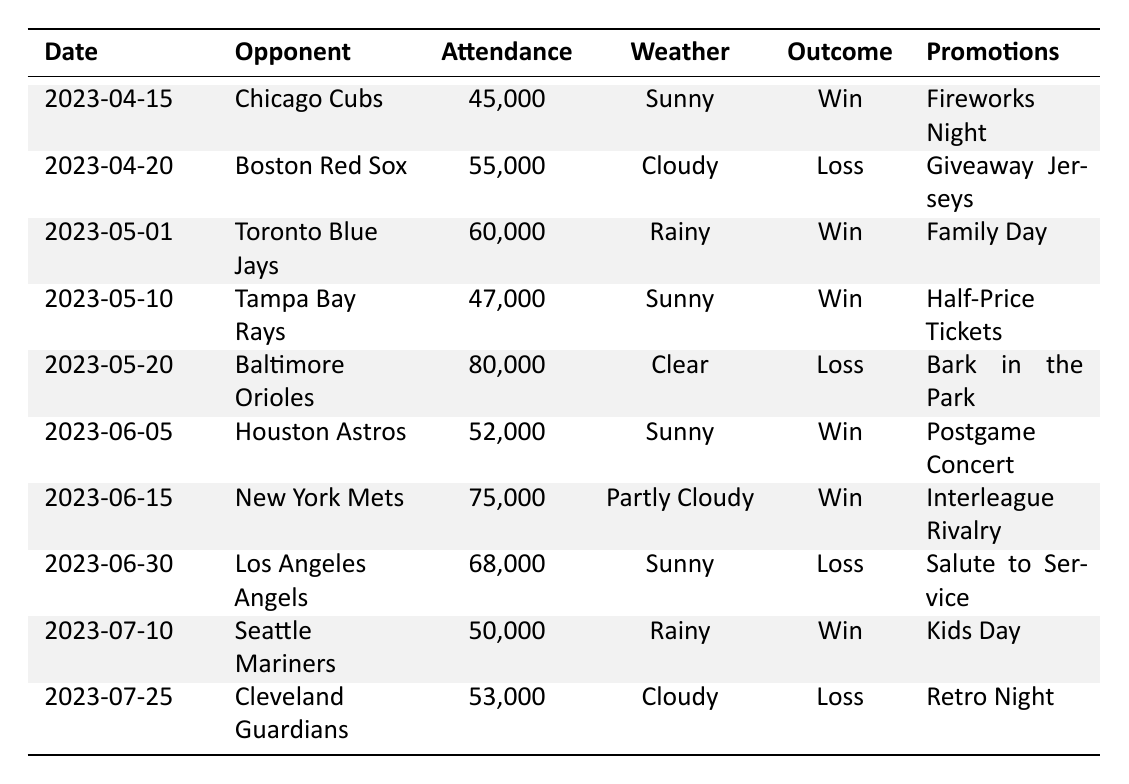What was the attendance for the game against the Baltimore Orioles on May 20, 2023? The attendance for the game against the Baltimore Orioles is listed in the table under Attendance for the date May 20, 2023. The value is 80,000.
Answer: 80,000 How many games did the New York Yankees win during this period? To determine the number of wins, we can count the rows where the Outcome is "Win". In the table, there are six wins on the dates: April 15, May 1, May 10, June 5, June 15, and July 10.
Answer: 6 What was the average attendance for games played on sunny days? The games on sunny days are: April 15 (45,000), May 10 (47,000), June 5 (52,000), June 30 (68,000), and July 10 (50,000). We sum these attendances: 45,000 + 47,000 + 52,000 + 68,000 + 50,000 = 262,000. There are 5 games, so the average attendance is 262,000 / 5 = 52,400.
Answer: 52,400 Did the Yankees ever have higher attendance when they had a promotional event? By reviewing the data, we notice that two games with high attendance (80,000 vs. Baltimore and 75,000 vs. New York Mets) coincided with promotional events ("Bark in the Park" and "Interleague Rivalry"). We conclude that there were two instances of high attendance on promotional event days.
Answer: Yes Which game had the highest attendance, and what was the outcome? The game with the highest attendance is listed in the table for May 20, 2023, against the Baltimore Orioles with 80,000 attendees. The outcome for that game is "Loss".
Answer: May 20, 2023, Loss What promotions were held for the games that had more than 60,000 attendees? The games with attendance over 60,000 are: May 1 (60,000, Family Day), May 20 (80,000, Bark in the Park), and June 15 (75,000, Interleague Rivalry). These games had promotions associated with them.
Answer: Family Day, Bark in the Park, Interleague Rivalry How many games were played in rainy weather, and what were the outcomes? The rainy weather games are on May 1 (Win), July 10 (Win), and there are two instances of rain recorded. Therefore, the outcomes for those games are counted.
Answer: 2 games: both wins What is the difference in attendance between the game on April 20 and that on June 30? We subtract the attendance of the game on June 30 (68,000) from the game on April 20 (55,000). The difference is 68,000 - 55,000 = 13,000.
Answer: 13,000 Where did the Yankees play on the day with the most attendees? The day with the most attendees is noted for May 20, 2023. The table indicates that the Yankees played at home against the Baltimore Orioles on that date.
Answer: At home against the Baltimore Orioles Was the attendance generally higher for wins or losses? To evaluate this, we will list the attendances for wins (45000, 60000, 47000, 52000, 75000, 50000) and losses (55000, 80000, 68000, 53000). The total attendance for wins is 2,85,000 and for losses is 2,41,000. Therefore, wins draw a larger attendance.
Answer: Wins have higher attendance 